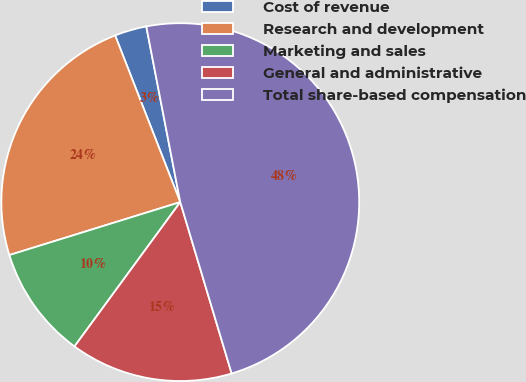Convert chart to OTSL. <chart><loc_0><loc_0><loc_500><loc_500><pie_chart><fcel>Cost of revenue<fcel>Research and development<fcel>Marketing and sales<fcel>General and administrative<fcel>Total share-based compensation<nl><fcel>2.89%<fcel>23.85%<fcel>10.15%<fcel>14.7%<fcel>48.4%<nl></chart> 